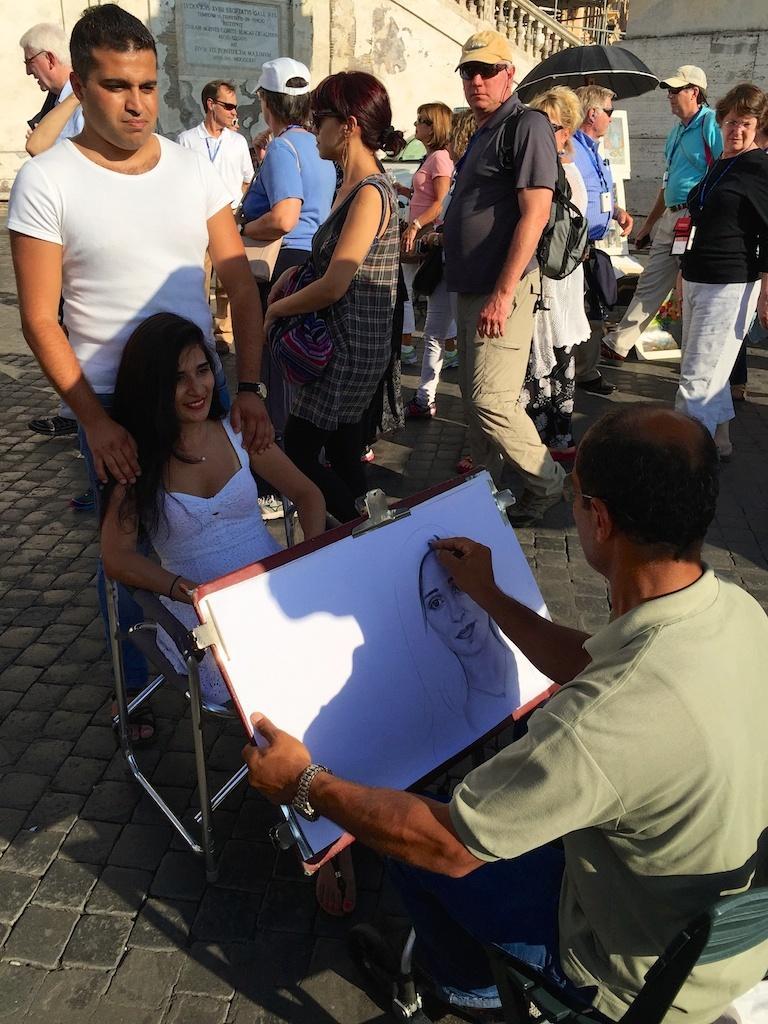Could you give a brief overview of what you see in this image? In this picture I can see a man drawing the picture of a woman at the bottom. On the left side a woman is sitting on the chair, in the middle a group of people are walking, at the top there is the wall. 